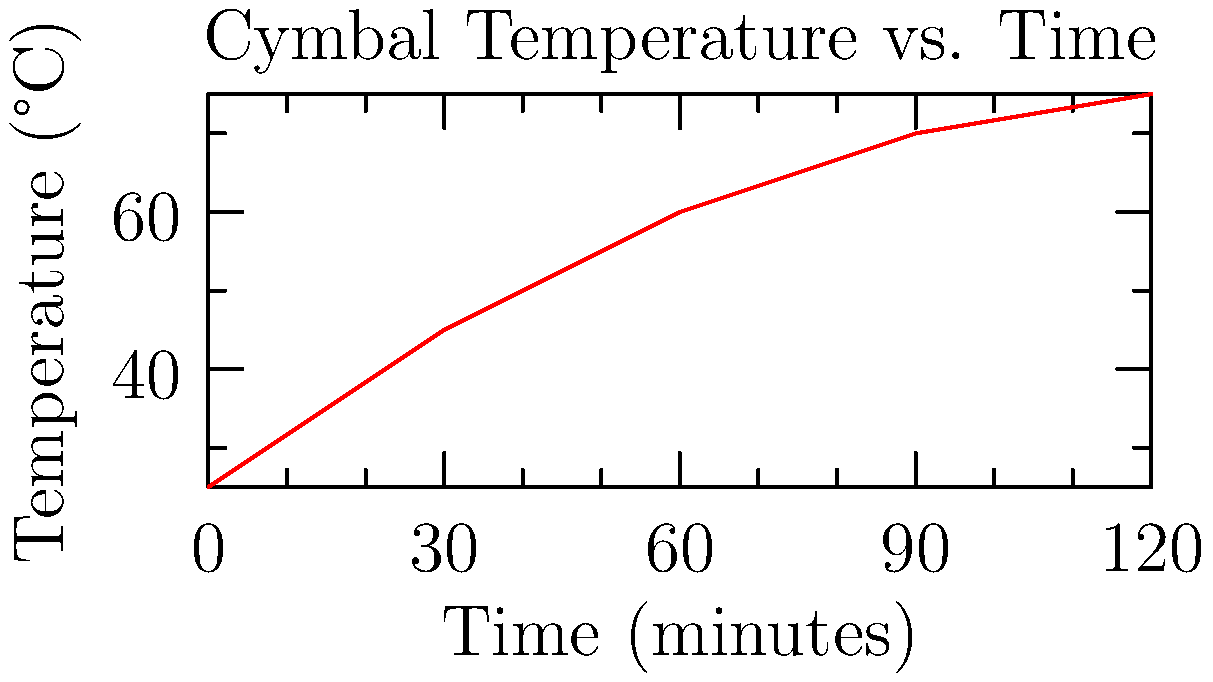During an intense Incubus drum solo, Jose Pasillas notices his cymbals heating up. The graph shows the temperature increase of a cymbal over time. Using Newton's Law of Cooling, estimate the final equilibrium temperature of the cymbal if the ambient temperature is 30°C. Assume the cooling rate is proportional to the temperature difference. To solve this problem, we'll use Newton's Law of Cooling and the given graph:

1. Newton's Law of Cooling states that the rate of temperature change is proportional to the difference between the object's temperature and the ambient temperature:

   $$\frac{dT}{dt} = -k(T - T_a)$$

   Where $T$ is the object's temperature, $T_a$ is the ambient temperature, and $k$ is the cooling constant.

2. At equilibrium, $\frac{dT}{dt} = 0$, so the object's temperature will no longer change.

3. From the graph, we can see that the temperature rise is slowing down, approaching an asymptote.

4. The equilibrium temperature ($T_{eq}$) will be where the heating rate equals the cooling rate.

5. We can estimate this by extrapolating the curve to where it becomes horizontal.

6. From the graph, it appears the temperature is leveling off around 75-80°C.

7. This makes sense because the equilibrium temperature must be higher than the ambient temperature (30°C) for heat to continue flowing from the cymbal to the surroundings.

Therefore, we can estimate the equilibrium temperature to be approximately 80°C.
Answer: 80°C 